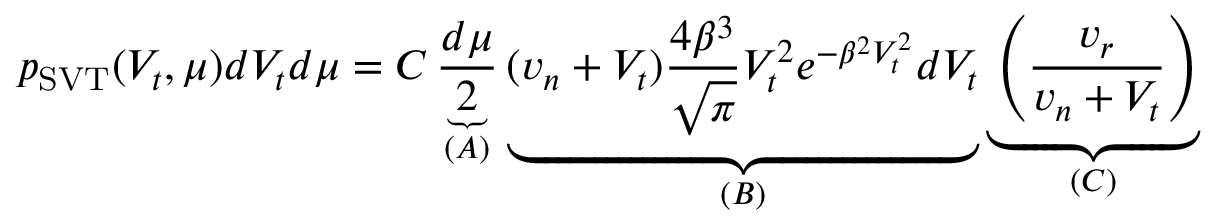<formula> <loc_0><loc_0><loc_500><loc_500>p _ { S V T } ( V _ { t } , \mu ) d V _ { t } d \mu = C \underbrace { \frac { d \mu } { 2 } } _ { ( A ) } \underbrace { ( v _ { n } + V _ { t } ) \frac { 4 \beta ^ { 3 } } { \sqrt { \pi } } V _ { t } ^ { 2 } e ^ { - \beta ^ { 2 } V _ { t } ^ { 2 } } d V _ { t } } _ { ( B ) } \underbrace { \left ( \frac { v _ { r } } { v _ { n } + V _ { t } } \right ) } _ { ( C ) }</formula> 